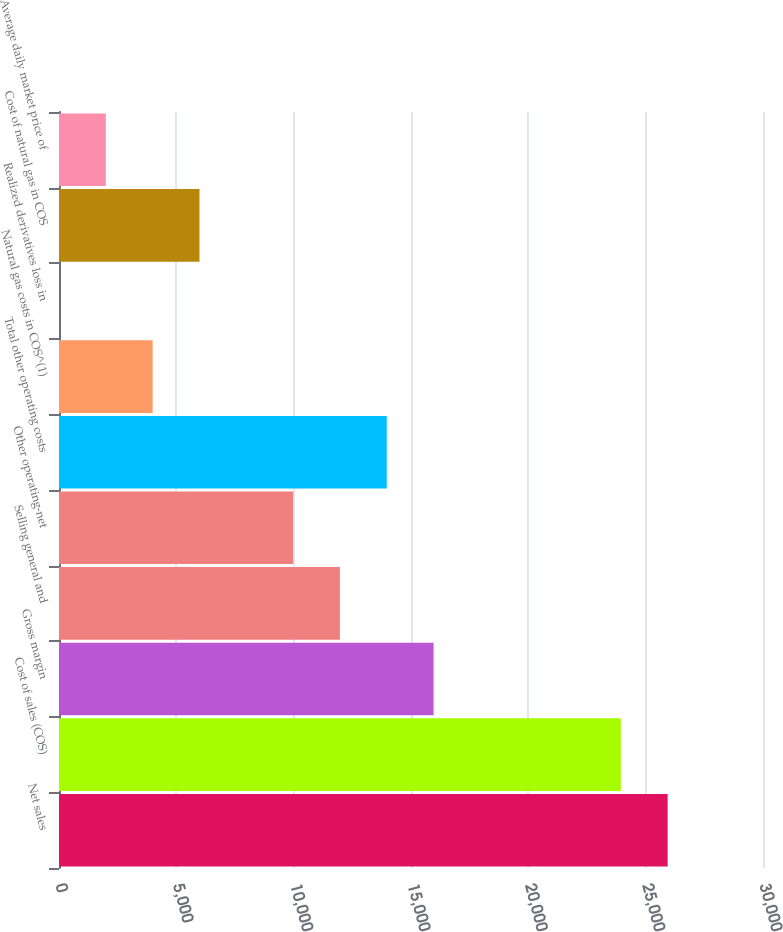<chart> <loc_0><loc_0><loc_500><loc_500><bar_chart><fcel>Net sales<fcel>Cost of sales (COS)<fcel>Gross margin<fcel>Selling general and<fcel>Other operating-net<fcel>Total other operating costs<fcel>Natural gas costs in COS^(1)<fcel>Realized derivatives loss in<fcel>Cost of natural gas in COS<fcel>Average daily market price of<nl><fcel>25937.5<fcel>23942.3<fcel>15961.6<fcel>11971.2<fcel>9976.02<fcel>13966.4<fcel>3990.45<fcel>0.07<fcel>5985.64<fcel>1995.26<nl></chart> 